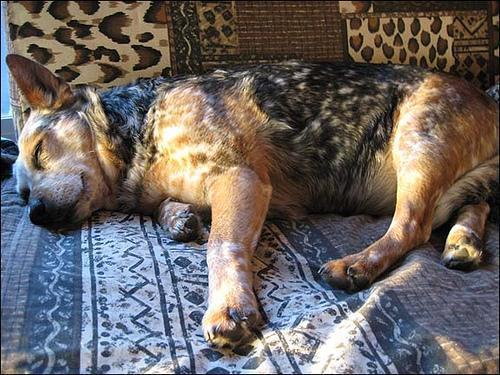How many pizzas are waiting to be baked?
Give a very brief answer. 0. 